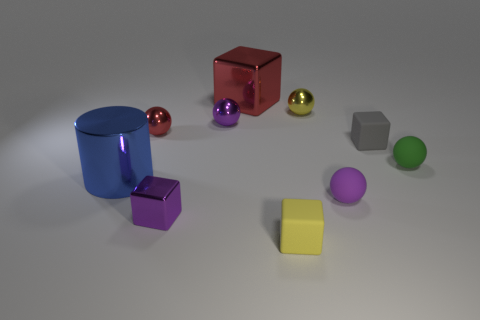Subtract all yellow shiny spheres. How many spheres are left? 4 Subtract all purple cubes. How many cubes are left? 3 Subtract all cylinders. How many objects are left? 9 Subtract all red cylinders. How many purple spheres are left? 2 Subtract all brown cubes. Subtract all brown cylinders. How many cubes are left? 4 Subtract all big red metal things. Subtract all small purple metallic things. How many objects are left? 7 Add 5 purple things. How many purple things are left? 8 Add 6 tiny purple shiny spheres. How many tiny purple shiny spheres exist? 7 Subtract 0 brown balls. How many objects are left? 10 Subtract 2 cubes. How many cubes are left? 2 